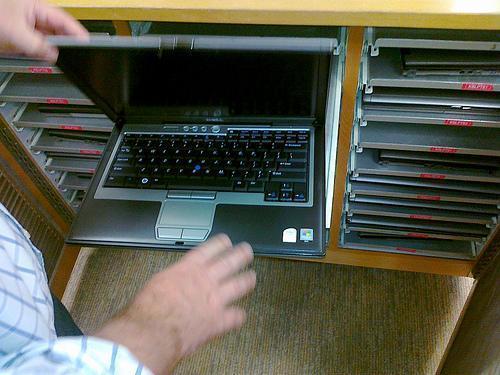How many laptops are opened?
Give a very brief answer. 1. 